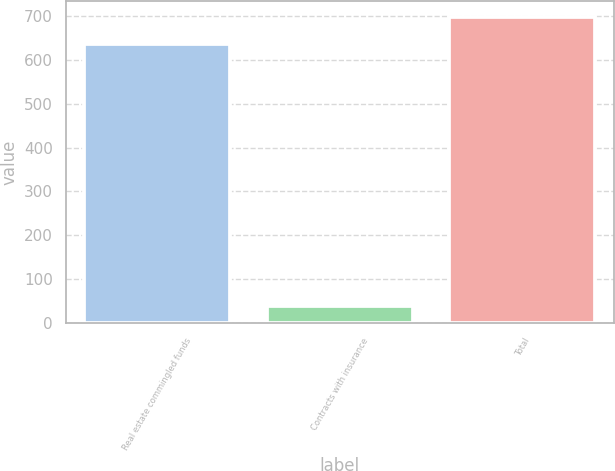<chart> <loc_0><loc_0><loc_500><loc_500><bar_chart><fcel>Real estate commingled funds<fcel>Contracts with insurance<fcel>Total<nl><fcel>635<fcel>40<fcel>698.5<nl></chart> 